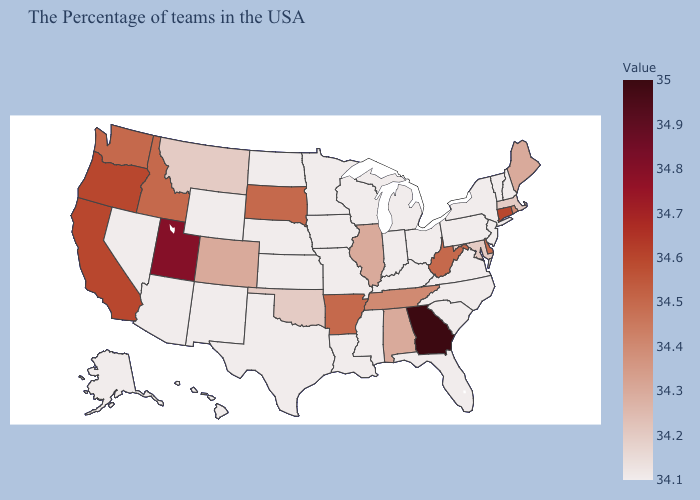Which states have the lowest value in the MidWest?
Concise answer only. Ohio, Michigan, Indiana, Wisconsin, Missouri, Minnesota, Iowa, Kansas, Nebraska, North Dakota. Is the legend a continuous bar?
Keep it brief. Yes. Which states have the highest value in the USA?
Write a very short answer. Georgia. Does Georgia have the highest value in the USA?
Concise answer only. Yes. Does New York have the highest value in the Northeast?
Give a very brief answer. No. Does Illinois have the lowest value in the USA?
Be succinct. No. Among the states that border Arizona , which have the highest value?
Give a very brief answer. Utah. Which states have the lowest value in the USA?
Write a very short answer. New Hampshire, Vermont, New York, New Jersey, Pennsylvania, Virginia, North Carolina, South Carolina, Ohio, Florida, Michigan, Kentucky, Indiana, Wisconsin, Mississippi, Louisiana, Missouri, Minnesota, Iowa, Kansas, Nebraska, Texas, North Dakota, Wyoming, New Mexico, Arizona, Nevada, Alaska, Hawaii. Among the states that border Oklahoma , does Colorado have the highest value?
Concise answer only. No. Among the states that border Nebraska , which have the lowest value?
Give a very brief answer. Missouri, Iowa, Kansas, Wyoming. 